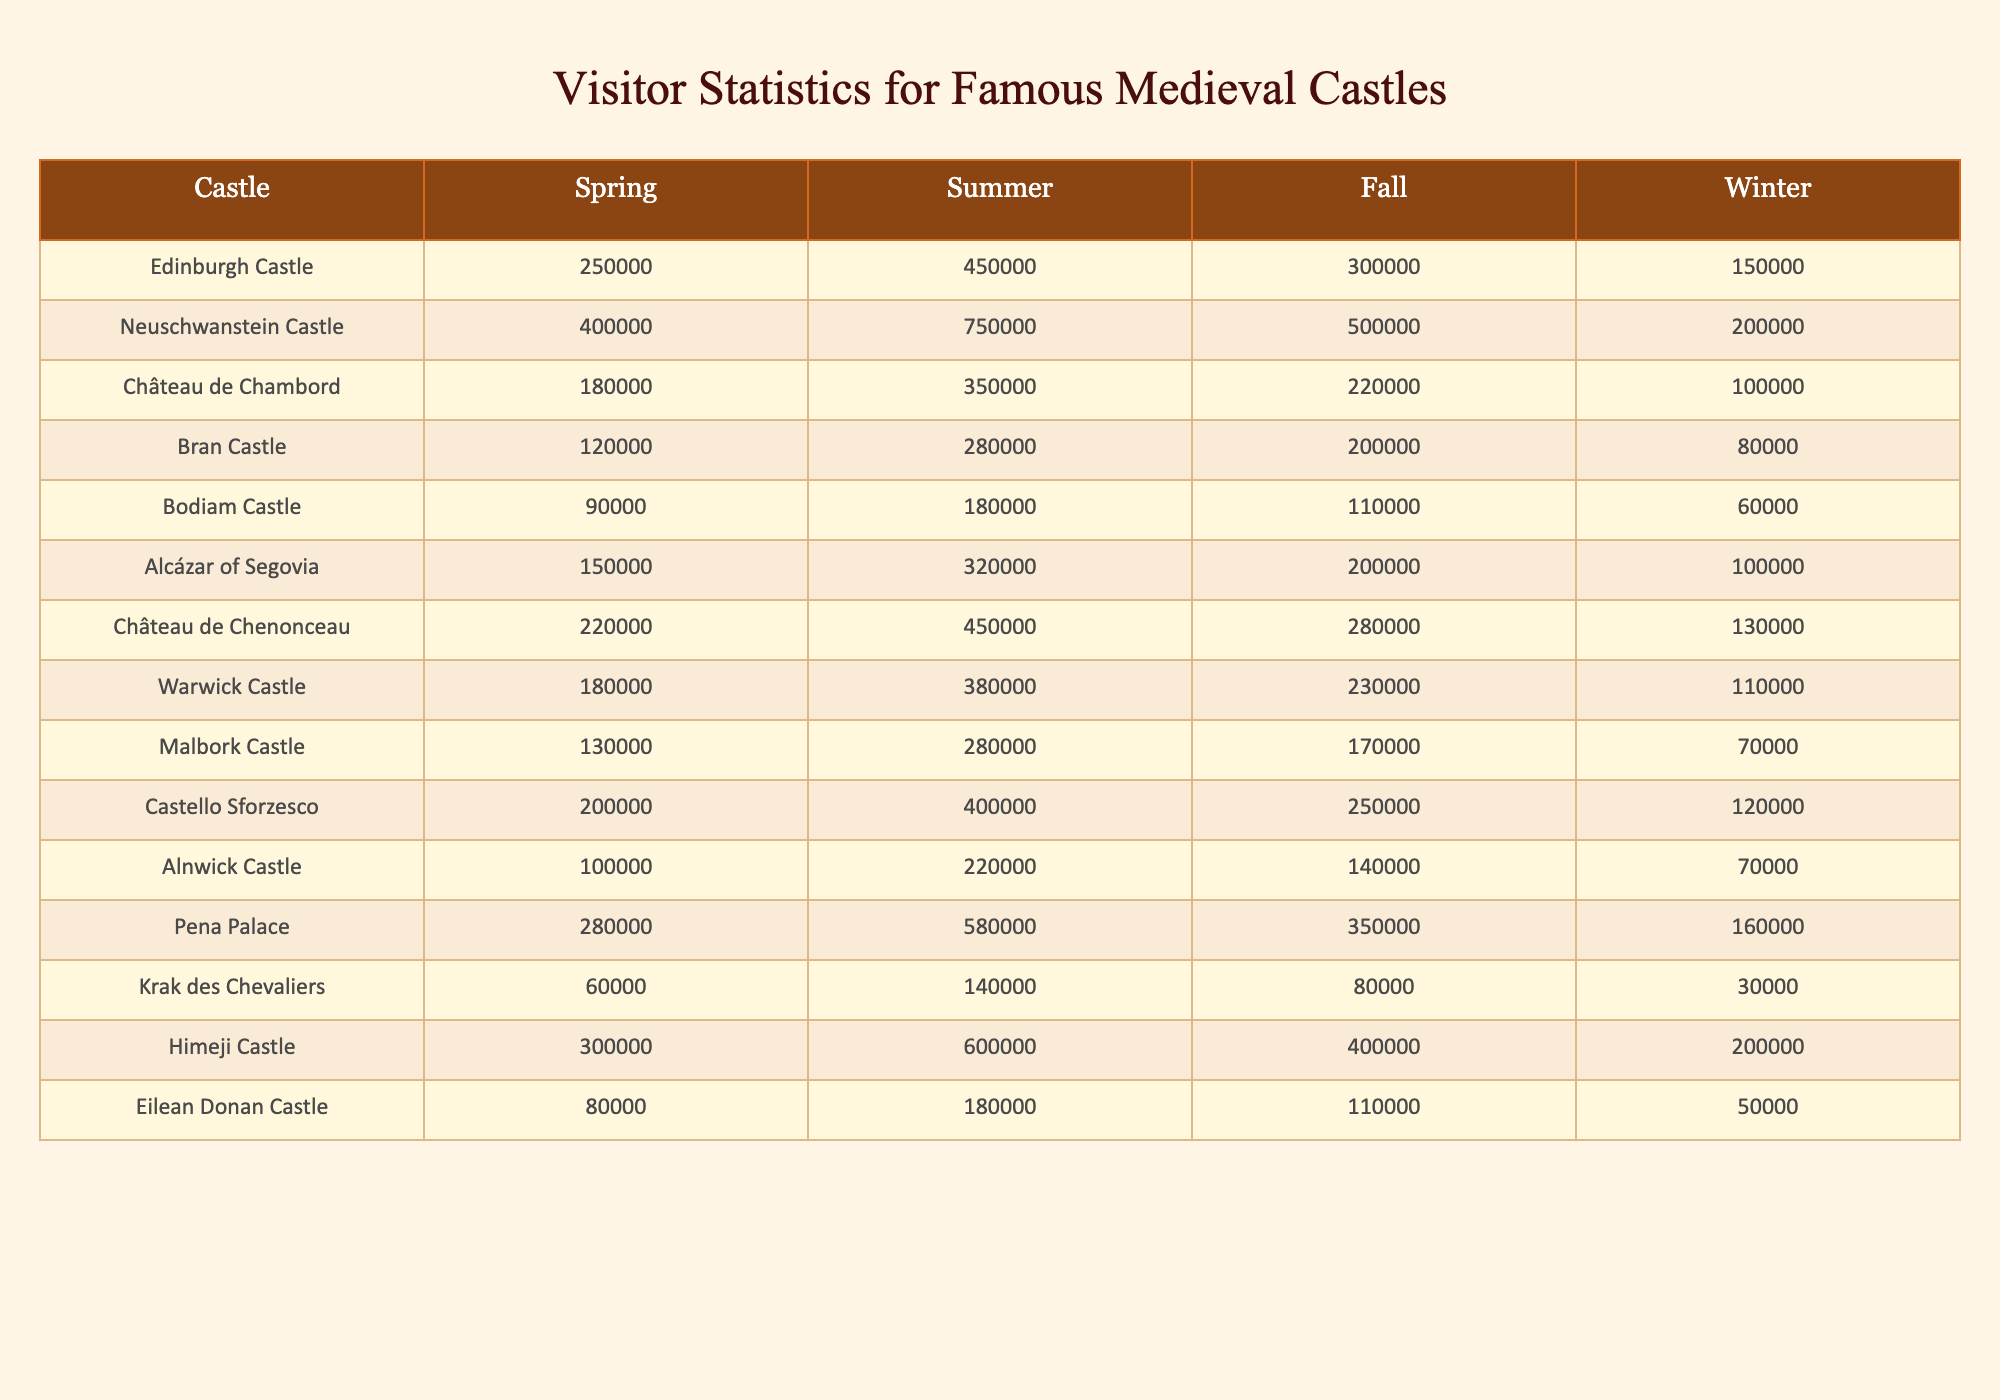What is the highest number of visitors to Neuschwanstein Castle in summer? The table shows the visitor statistics for each castle and season. For Neuschwanstein Castle in summer, the visitors are listed as 750,000.
Answer: 750,000 Which season has the least visitors for Bran Castle? By examining the data for Bran Castle, we see that the least number of visitors is in winter, with 80,000 visitors.
Answer: 80,000 What is the total number of visitors to the Château de Chenonceau in spring and fall? To find this, we add the visitors in spring (220,000) and fall (280,000) for the Château de Chenonceau. Therefore, 220,000 + 280,000 equals 500,000 visitors in those two seasons.
Answer: 500,000 Did Himeji Castle attract more visitors in summer or in winter? The data reveals that Himeji Castle had 600,000 visitors in summer and 200,000 in winter. Thus, it attracted more visitors in summer.
Answer: Yes What is the average number of visitors for Eilean Donan Castle across all seasons? The visitor numbers for Eilean Donan Castle in each season are 80,000 (spring), 180,000 (summer), 110,000 (fall), and 50,000 (winter). Adding these gives us 420,000 total visitors. Dividing by the 4 seasons, the average is 420,000 / 4, which equals 105,000.
Answer: 105,000 Which castle had a significant increase in visitors from spring to summer and what is the value of that increase? To assess the increase from spring to summer, we examine the visitor counts: for Alcázar of Segovia, spring had 150,000 and summer saw 320,000 visitors. To find the increase, we subtract spring visitors (150,000) from summer visitors (320,000), resulting in an increase of 170,000 visitors.
Answer: 170,000 Which castle had the second highest visitor number in the fall? Looking at the fall visitor numbers, Neuschwanstein Castle had 500,000 visitors and the next highest number is for Château de Chambord with 220,000 visitors, establishing it as the second highest.
Answer: Château de Chambord Is the total number of winter visitors across all castles greater than 2 million? We can calculate the total winter visitors by adding all winter visitor numbers: 150,000 + 200,000 + 100,000 + 80,000 + 60,000 + 100,000 + 130,000 + 110,000 + 70,000 + 120,000 + 70,000 + 200,000 + 30,000 + 50,000 = 1,620,000, which is less than 2 million.
Answer: No What is the difference in visitors between summer and winter for the Château de Chambord? For the Château de Chambord, the summer visitors are listed as 350,000, while winter visitors are 100,000. Therefore, the difference is 350,000 - 100,000 = 250,000.
Answer: 250,000 Which castle shows the largest winter to summer visitor increase? To find the largest increase from winter to summer, we calculate for each castle: Neuschwanstein Castle (200,000), Château de Chambord (250,000), Bran Castle (200,000), and so on. Calculating all, we find Pena Palace had the largest increase: 580,000 (summer) - 160,000 (winter) = 420,000.
Answer: Pena Palace 